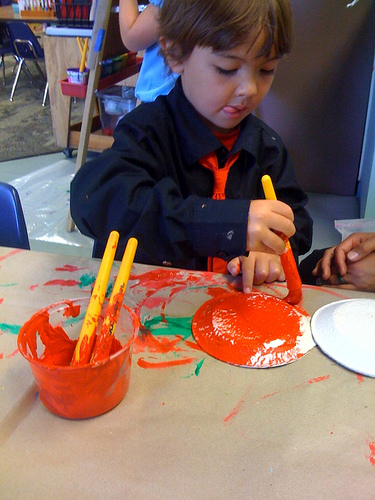What activity is the child engaged in? The child appears to be painting, as indicated by the cup of red paint and brushes, as well as the paper in front of him that already has some strokes of red paint. What can we infer about the child's environment? The child is likely in a classroom setting designed for creative activities, indicated by the presence of art supplies and the protective covering on the table, which is common in educational or daycare environments that encourage artistic expression. 